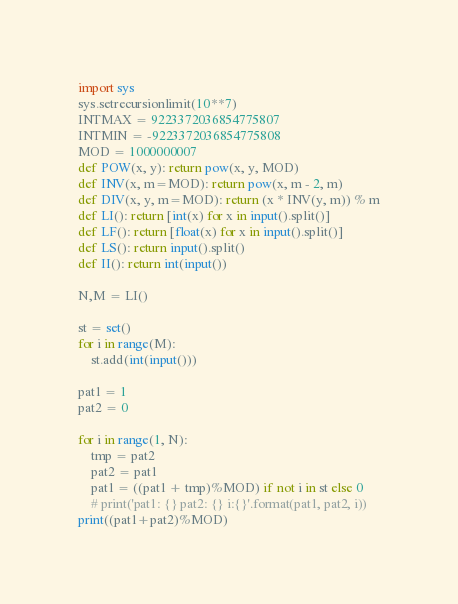Convert code to text. <code><loc_0><loc_0><loc_500><loc_500><_Python_>import sys
sys.setrecursionlimit(10**7)
INTMAX = 9223372036854775807
INTMIN = -9223372036854775808
MOD = 1000000007
def POW(x, y): return pow(x, y, MOD)
def INV(x, m=MOD): return pow(x, m - 2, m)
def DIV(x, y, m=MOD): return (x * INV(y, m)) % m
def LI(): return [int(x) for x in input().split()]
def LF(): return [float(x) for x in input().split()]
def LS(): return input().split()
def II(): return int(input())

N,M = LI()

st = set()
for i in range(M):
    st.add(int(input()))

pat1 = 1
pat2 = 0

for i in range(1, N):
    tmp = pat2
    pat2 = pat1
    pat1 = ((pat1 + tmp)%MOD) if not i in st else 0
    # print('pat1: {} pat2: {} i:{}'.format(pat1, pat2, i))
print((pat1+pat2)%MOD)
</code> 